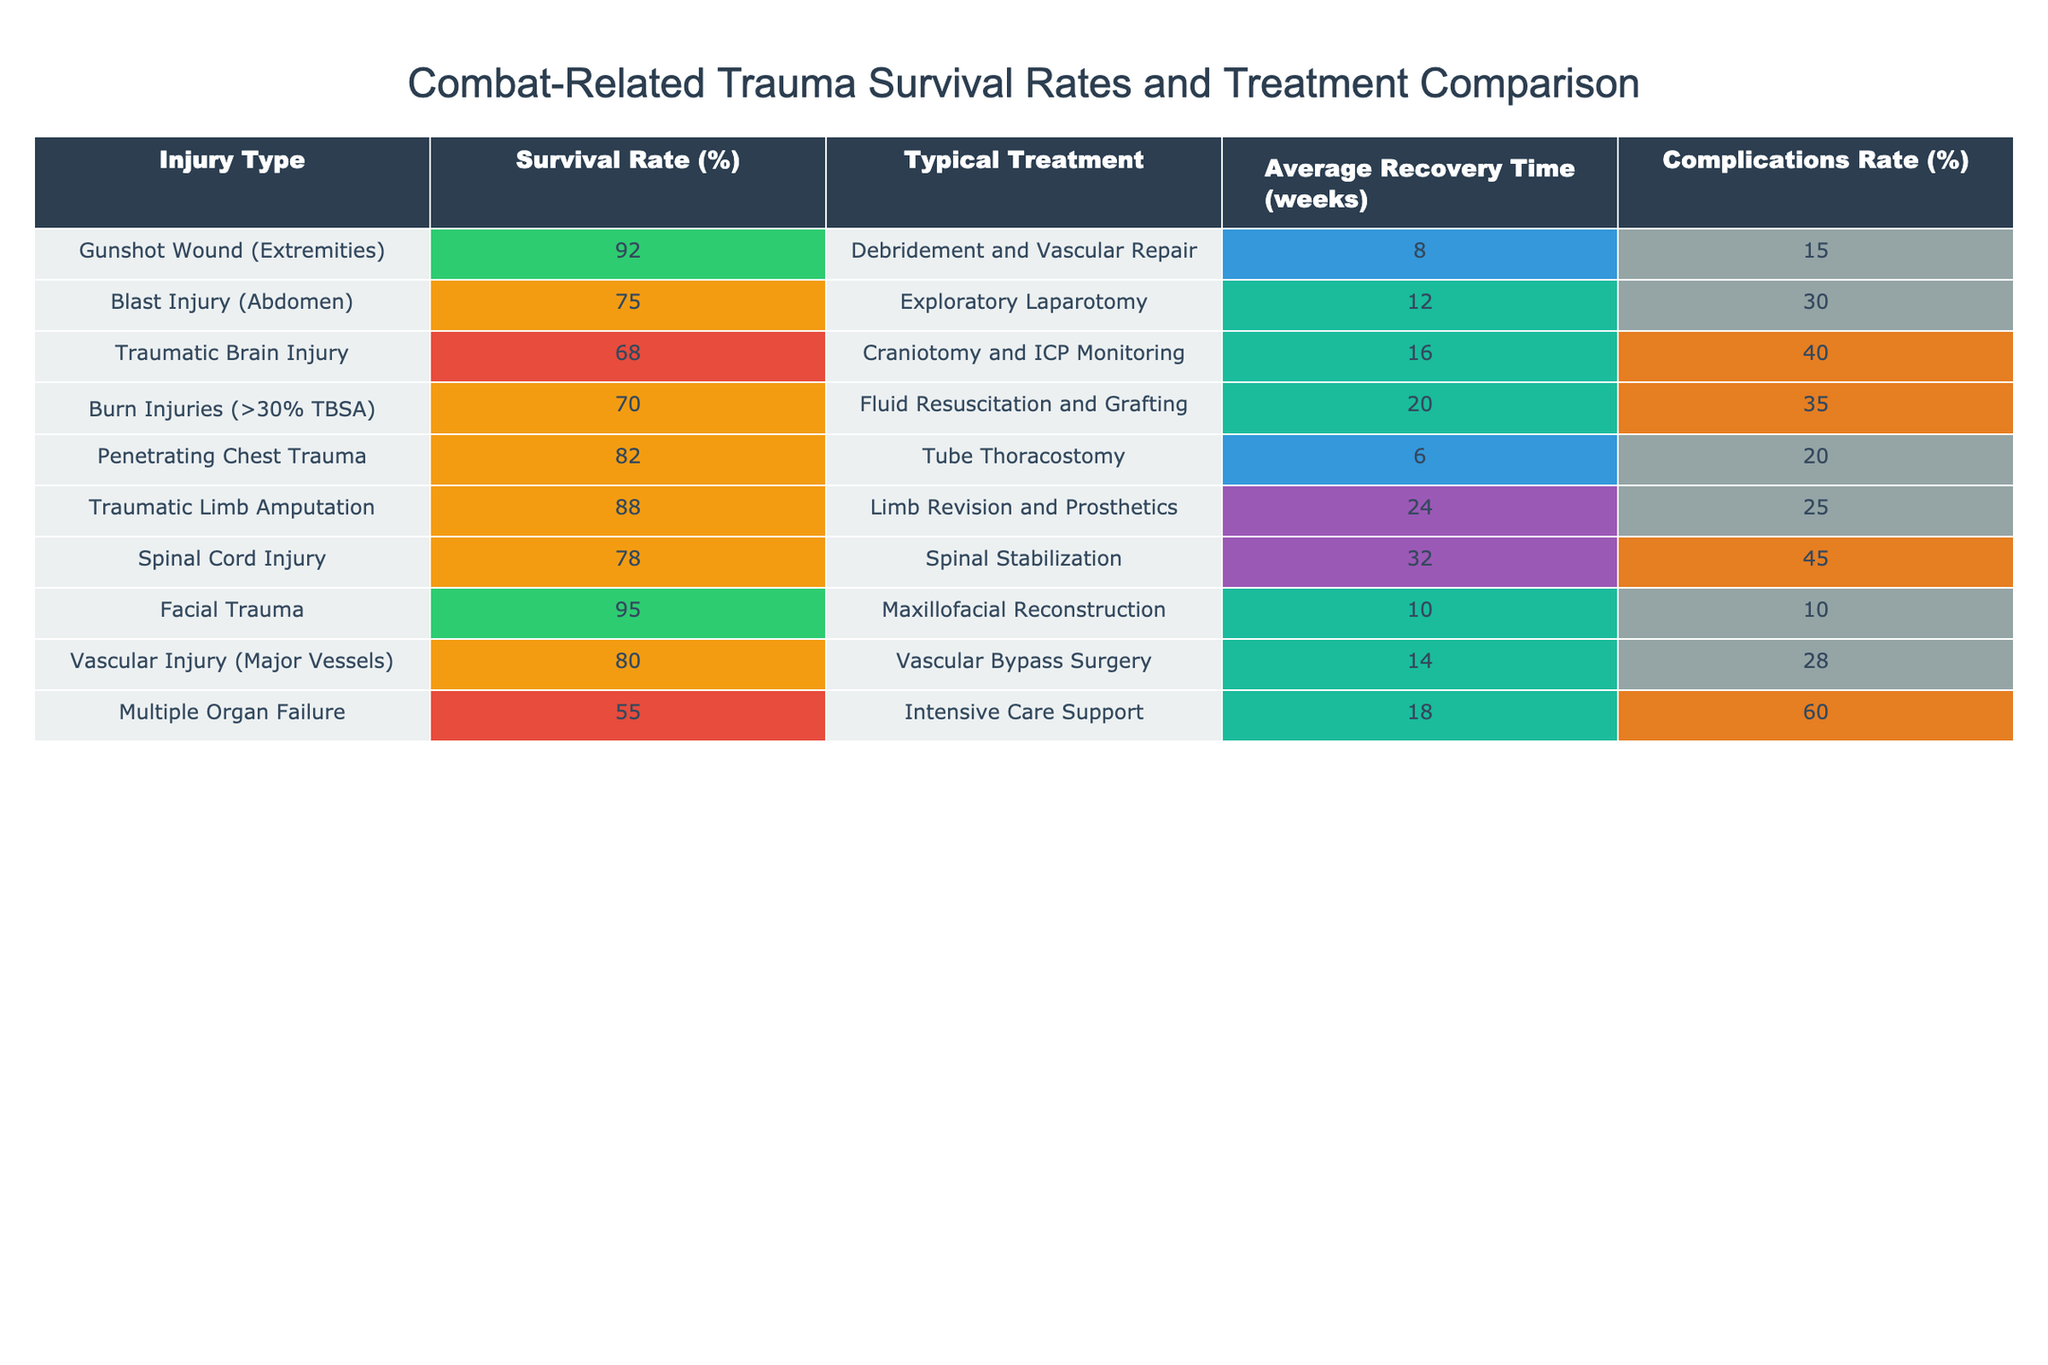What is the survival rate for Gunshot Wound (Extremities)? The table indicates that the survival rate for Gunshot Wound (Extremities) is listed as 92%.
Answer: 92% Which injury type has the lowest survival rate? The injury with the lowest survival rate is Multiple Organ Failure, which has a survival rate of 55%.
Answer: Multiple Organ Failure What is the average recovery time for Blast Injury (Abdomen) and Traumatic Brain Injury combined? The average recovery time for Blast Injury (Abdomen) is 12 weeks, and for Traumatic Brain Injury, it is 16 weeks. Adding these together gives 12 + 16 = 28 weeks. To find the average, divide by 2 to get 28/2 = 14 weeks.
Answer: 14 weeks True or False: The survival rate for Facial Trauma is above 90%. According to the table, the survival rate for Facial Trauma is 95%, which is indeed above 90%.
Answer: True If a patient has a Traumatic Limb Amputation and a Blast Injury (Abdomen), what would be the difference in complications rate? The complications rate for Traumatic Limb Amputation is 25%, while for Blast Injury (Abdomen) it is 30%. The difference between them is 30 - 25 = 5%.
Answer: 5% What is the total survival rate for the two injury types with the highest rates? The two highest survival rates are for Facial Trauma (95%) and Gunshot Wound (Extremities) (92%). Adding these together gives 95 + 92 = 187%. To find the total, the sum is 187%.
Answer: 187% How does the survival rate for Spinal Cord Injury compare to that of Penetrating Chest Trauma? The survival rate for Spinal Cord Injury is 78%, while for Penetrating Chest Trauma it is 82%. Comparing the two rates, Penetrating Chest Trauma has a higher survival rate by 82 - 78 = 4%.
Answer: 4% higher Which injury type has the longest average recovery time? The injury type with the longest average recovery time is Spinal Cord Injury, with a recovery time of 32 weeks, which is longer than any other type listed in the table.
Answer: Spinal Cord Injury What is the survival rate of Vascular Injury (Major Vessels), and is it greater than the survival rate for Burn Injuries (>30% TBSA)? The survival rate for Vascular Injury (Major Vessels) is 80%, while for Burn Injuries (>30% TBSA) it is 70%. Since 80% is greater than 70%, the answer is yes.
Answer: Yes 